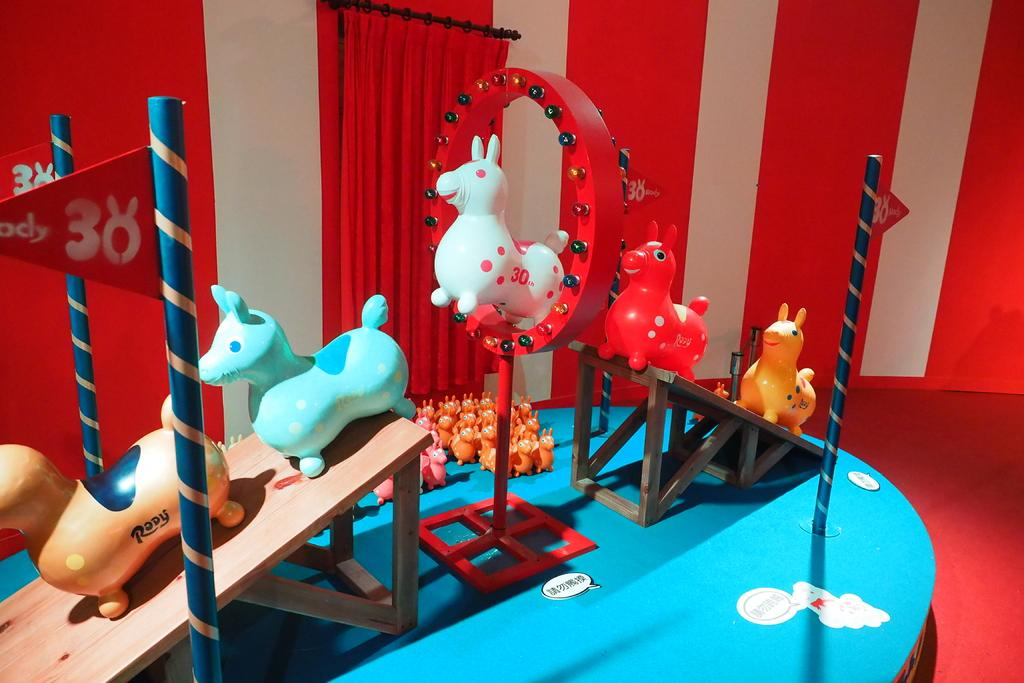What type of objects can be seen on the table in the image? There are toys, poles, and benches on the table in the image. What might the toys be used for? The toys could be used for play or decoration. What are the poles used for in the image? The purpose of the poles is not clear from the image, but they could be used for support or as part of a structure. What are the benches used for in the image? The benches could be used for sitting or as part of a display. What is present at the top of the image? There is a curtain at the top of the image. What type of knowledge can be gained from the line in the image? There is no line present in the image, so no knowledge can be gained from it. 